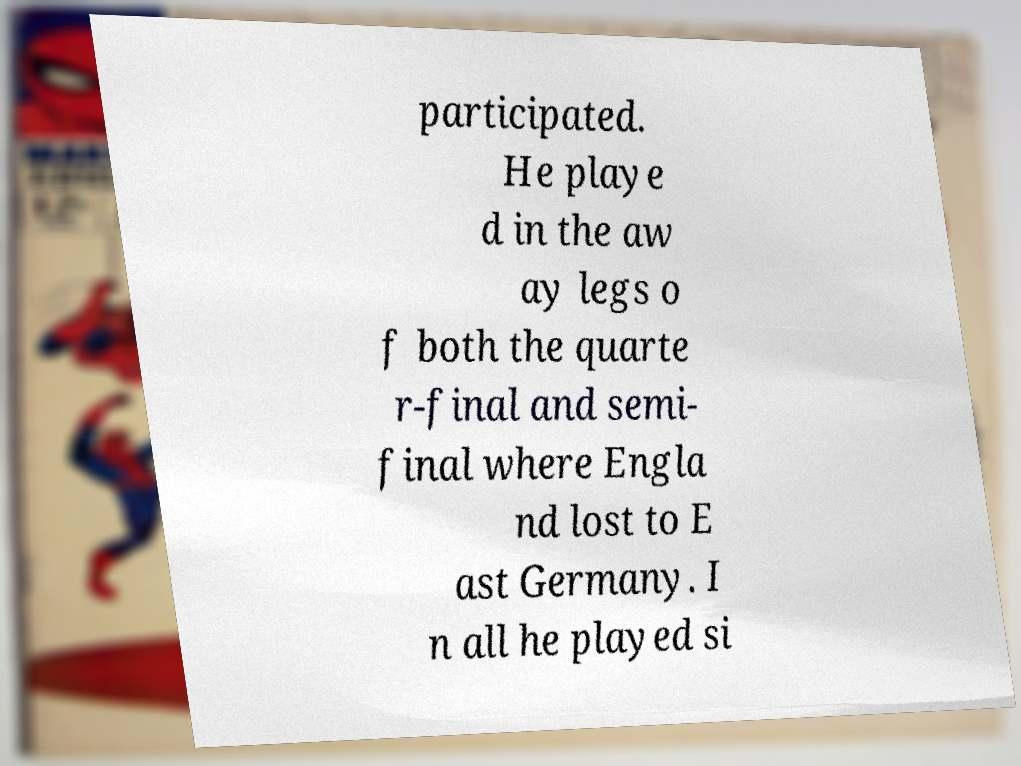Please read and relay the text visible in this image. What does it say? participated. He playe d in the aw ay legs o f both the quarte r-final and semi- final where Engla nd lost to E ast Germany. I n all he played si 